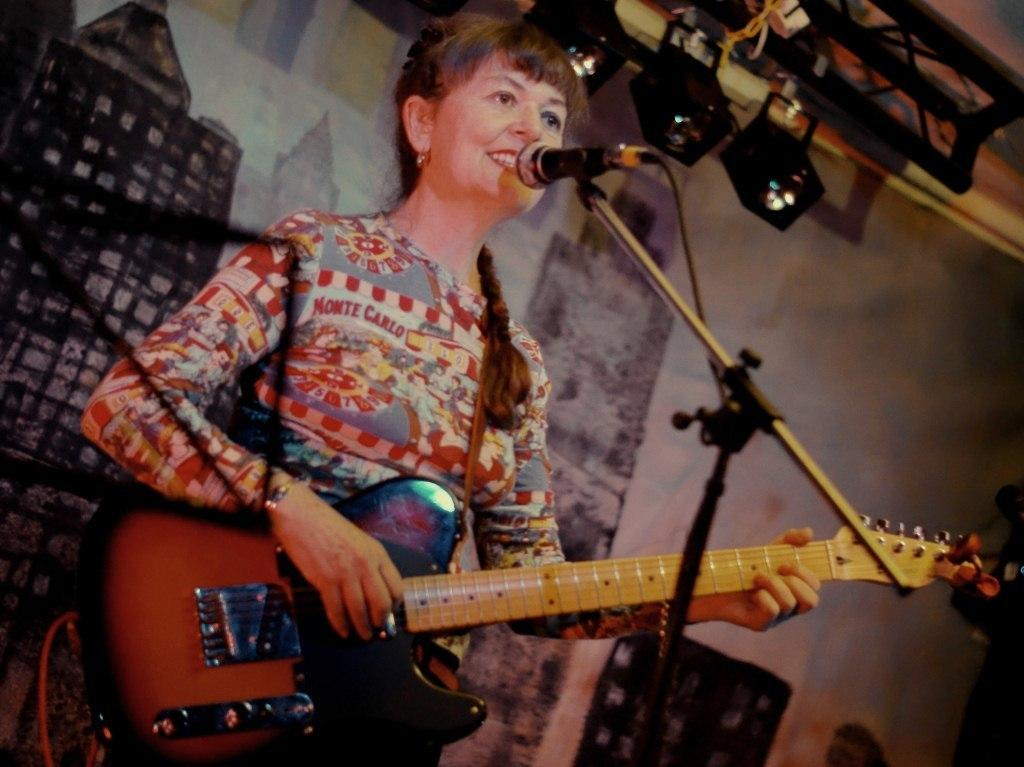Who is the main subject in the image? There is a woman in the image. What is the woman holding in the image? The woman is holding a guitar. What is the woman doing with the guitar? The woman is playing the guitar. What is in front of the woman that might be used for amplifying her voice? There is a microphone in front of the woman. What is supporting the microphone in the image? There is a microphone stand in front of the woman. What can be seen in the background of the image? There is a wall in the background of the image. What can be seen illuminating the scene in the image? There are lights visible in the image. What is the weight of the woman's thoughts while playing the guitar in the image? The weight of the woman's thoughts cannot be determined from the image, as thoughts are not visible or measurable. 